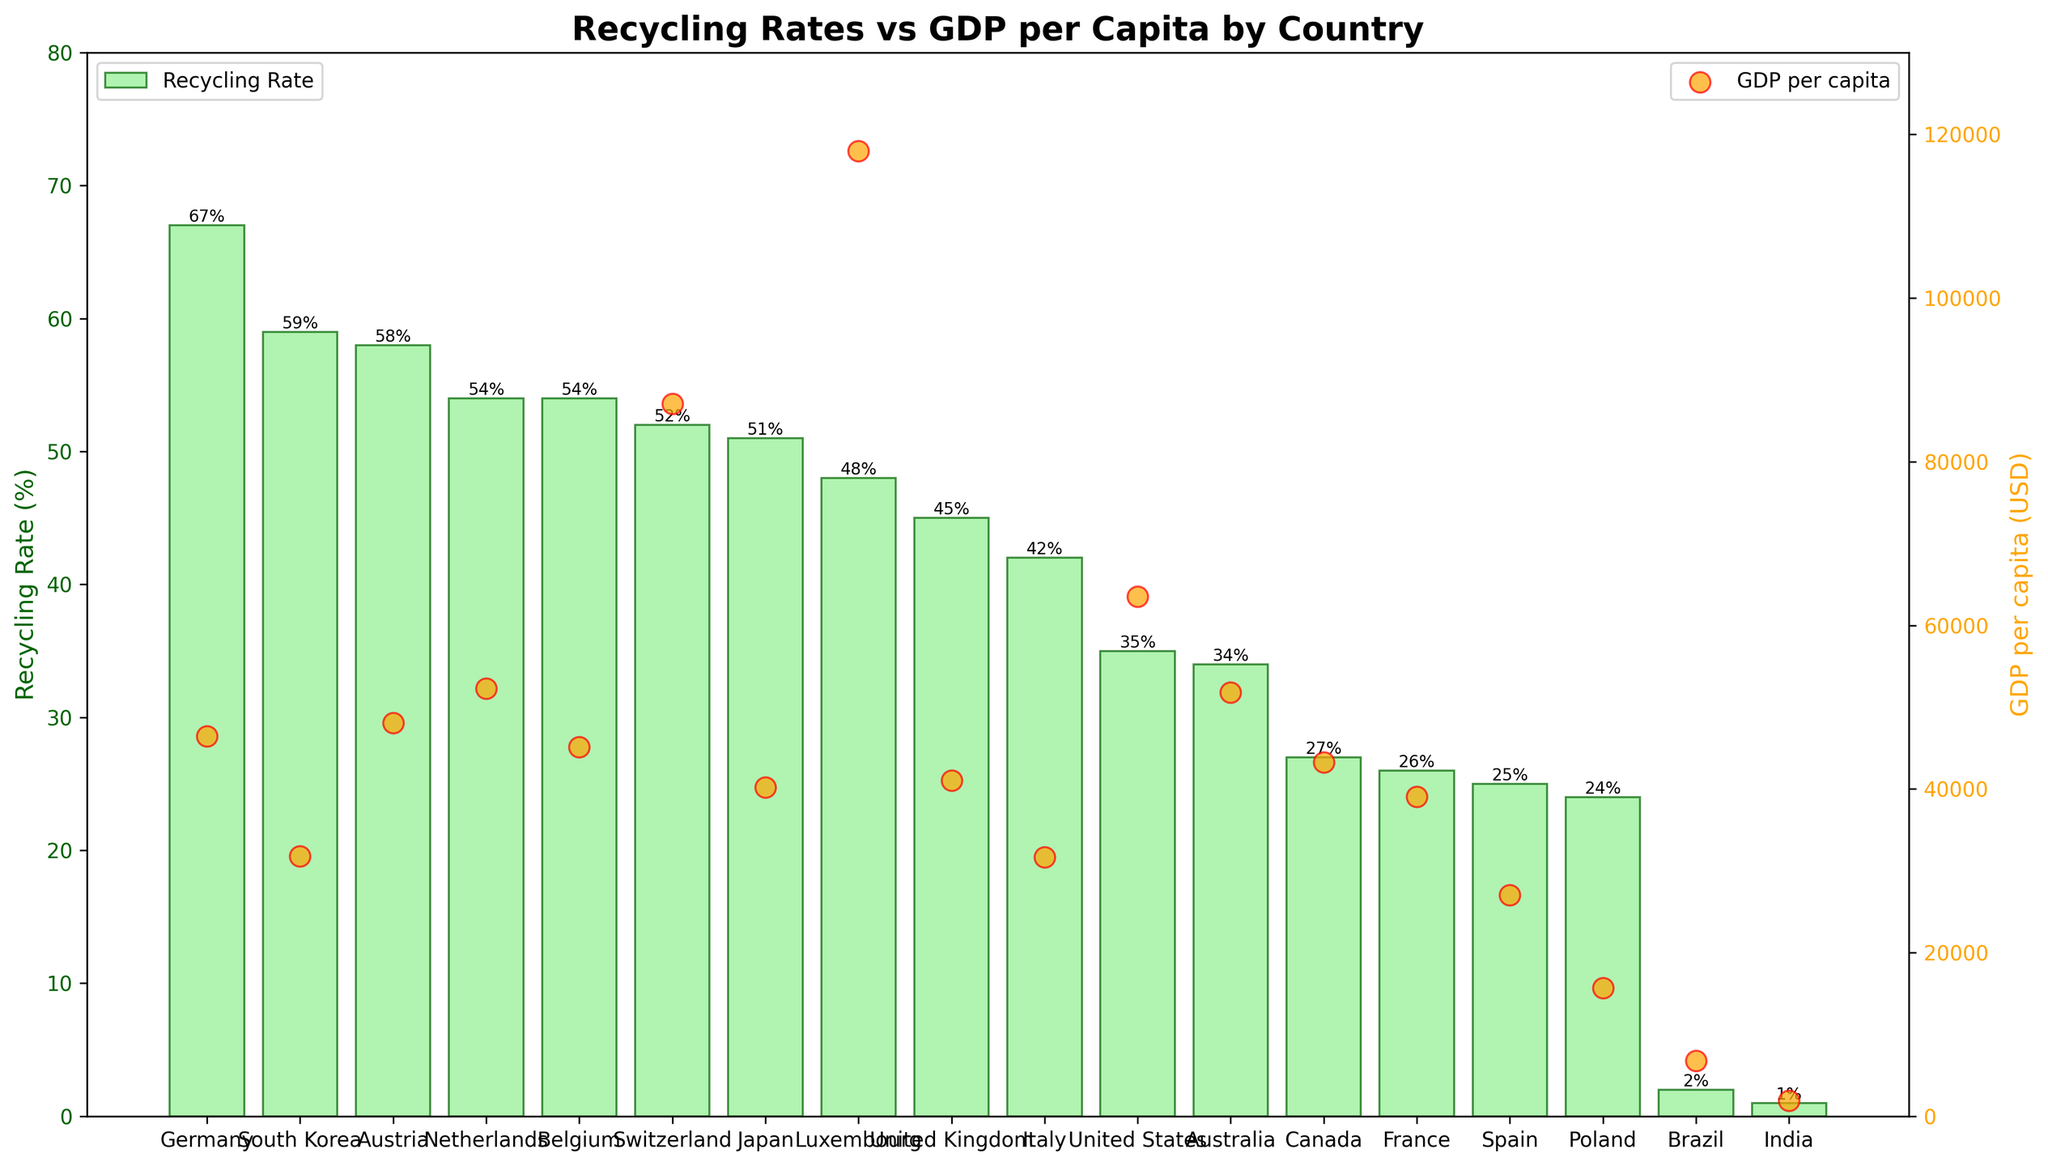What country has the highest recycling rate? Looking at the bars in the figure, the tallest bar represents the highest recycling rate. Germany's bar is the highest.
Answer: Germany Which country has the lowest GDP per capita? Referring to the scatter plot, locate the point that is closest to the bottom of the chart. India's point is the lowest on the vertical axis.
Answer: India What is the difference in recycling rates between Germany and the United States? Find the height of Germany's bar (67%) and the United States' bar (35%). Subtract the U.S. rate from Germany's rate: 67% - 35% = 32%.
Answer: 32% Which countries have a recycling rate over 50%? Refer to the bars taller than the 50% mark on the y-axis: Germany, South Korea, Austria, Netherlands, Belgium, Switzerland, and Japan.
Answer: Germany, South Korea, Austria, Netherlands, Belgium, Switzerland, Japan How do the recycling rates of Luxembourg and Canada compare? Compare the heights of Luxembourg and Canada's bars. Luxembourg has a higher recycling rate (48%) while Canada has a lower rate (27%).
Answer: Luxembourg has a higher recycling rate What is the average GDP per capita of the top five countries with the highest recycling rates? Identify the top five countries with the highest recycling rates: Germany, South Korea, Austria, Netherlands, and Belgium. Sum their GDPs: 46445 + 31762 + 48105 + 52304 + 45159 = 223775. Divide by 5: 223775 / 5 = 44755.
Answer: 44755 USD Are there any countries with high recycling rates but relatively low GDP per capita? Look for countries with bars greater than 50% but points lower on the y-axis of the scatter plot. South Korea (59%, 31,762 USD) stands out.
Answer: South Korea Which country has a higher recycling rate, Japan or Australia, and by how much? Compare the heights of Japan's (51%) and Australia's (34%) bars. Subtract Australia's rate from Japan's rate: 51% - 34% = 17%.
Answer: Japan, 17% Which country has a greater difference between its recycling rate and GDP per capita? To answer this, look for extreme values in both metrics. India has a very low GDP per capita (1,901 USD) and a low recycling rate (1%). This large discrepancy indicates a significant difference.
Answer: India How does the GDP per capita of Switzerland compare to the recycling rate of Brazil? Find Switzerland's GDP per capita (87,097 USD) and Brazil's recycling rate (2%). This question juxtaposes a high GDP with an extremely low recycling rate.
Answer: Switzerland's GDP per capita is much higher than Brazil's recycling rate in percentage terms 